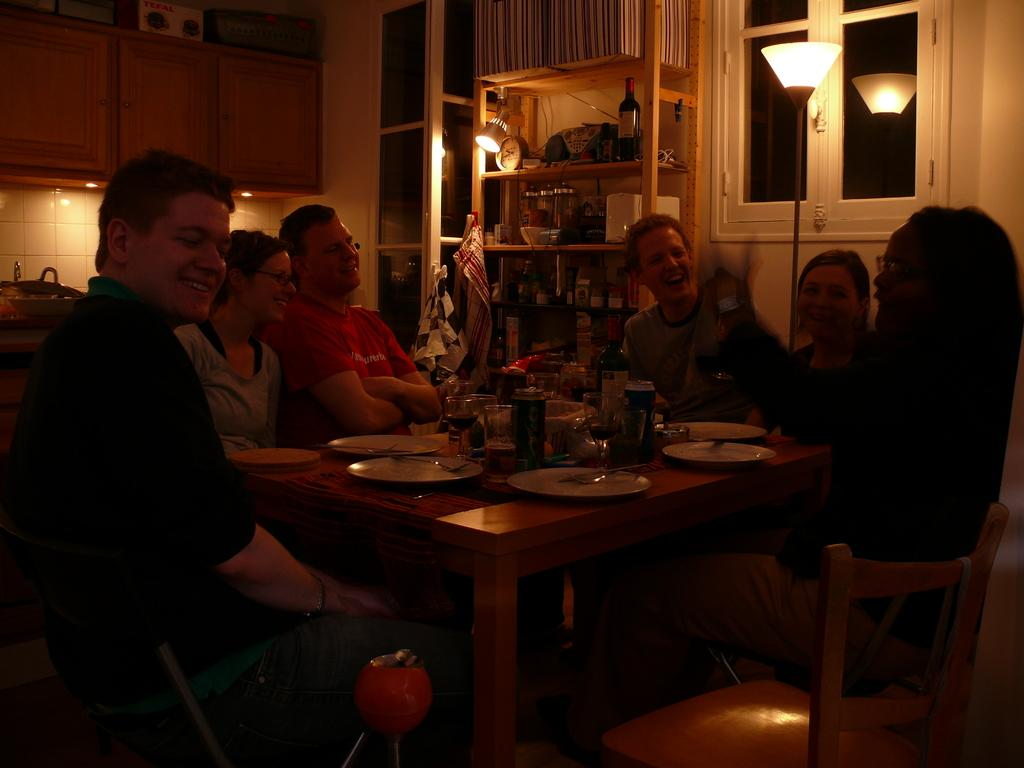Who or what is present in the image? There are people in the image. What are the people doing in the image? The people are sitting on chairs. Can you describe the lighting in the image? The light in the image is dim. What is the view from the window in the image? There is no window present in the image, so it is not possible to describe a view. 